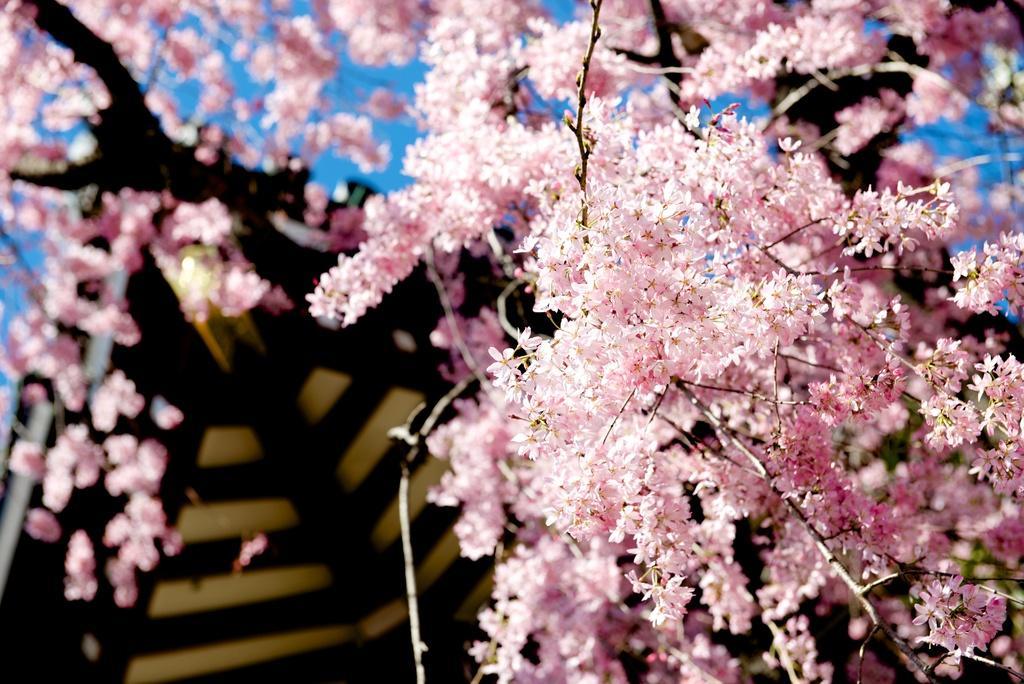How would you summarize this image in a sentence or two? In this image we can see flowers and sky. 